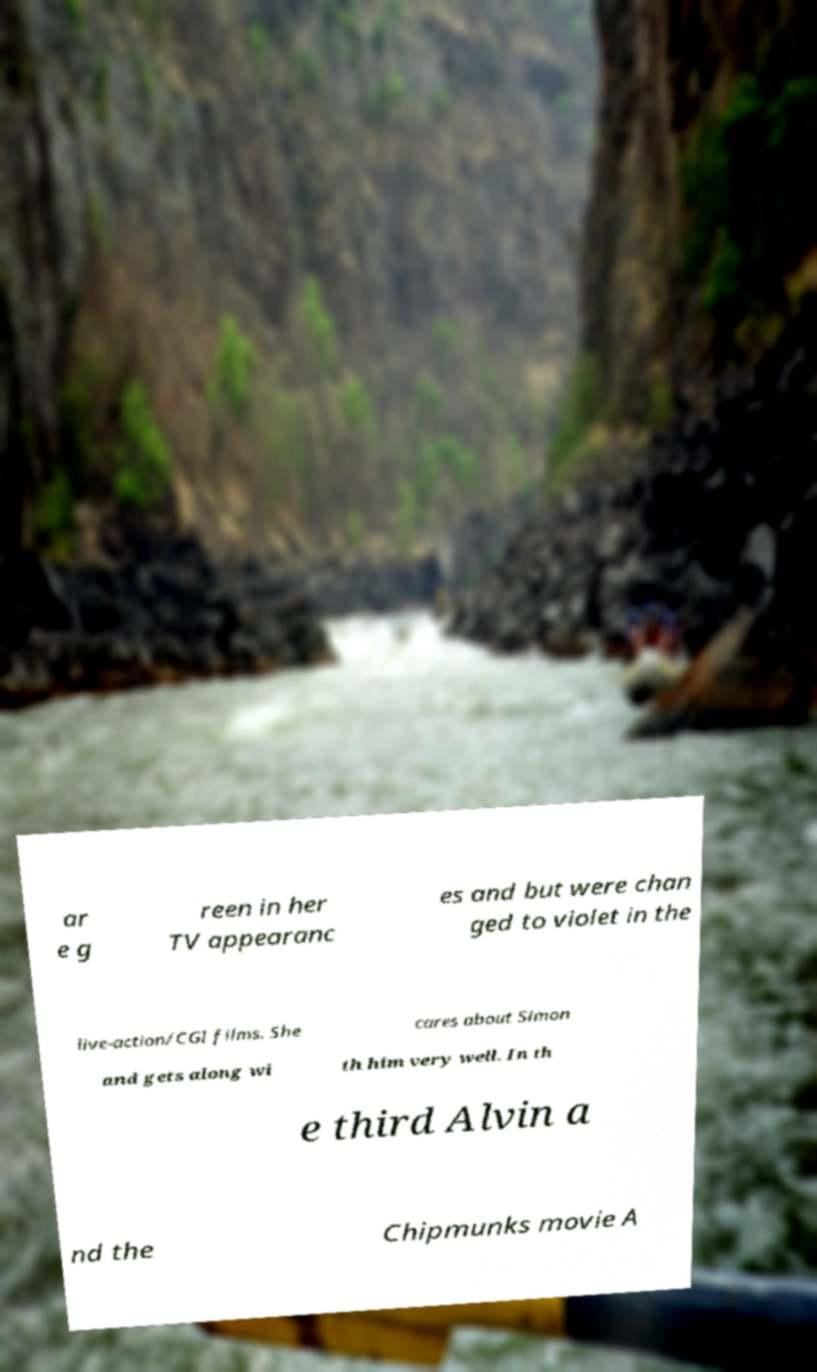What messages or text are displayed in this image? I need them in a readable, typed format. ar e g reen in her TV appearanc es and but were chan ged to violet in the live-action/CGI films. She cares about Simon and gets along wi th him very well. In th e third Alvin a nd the Chipmunks movie A 